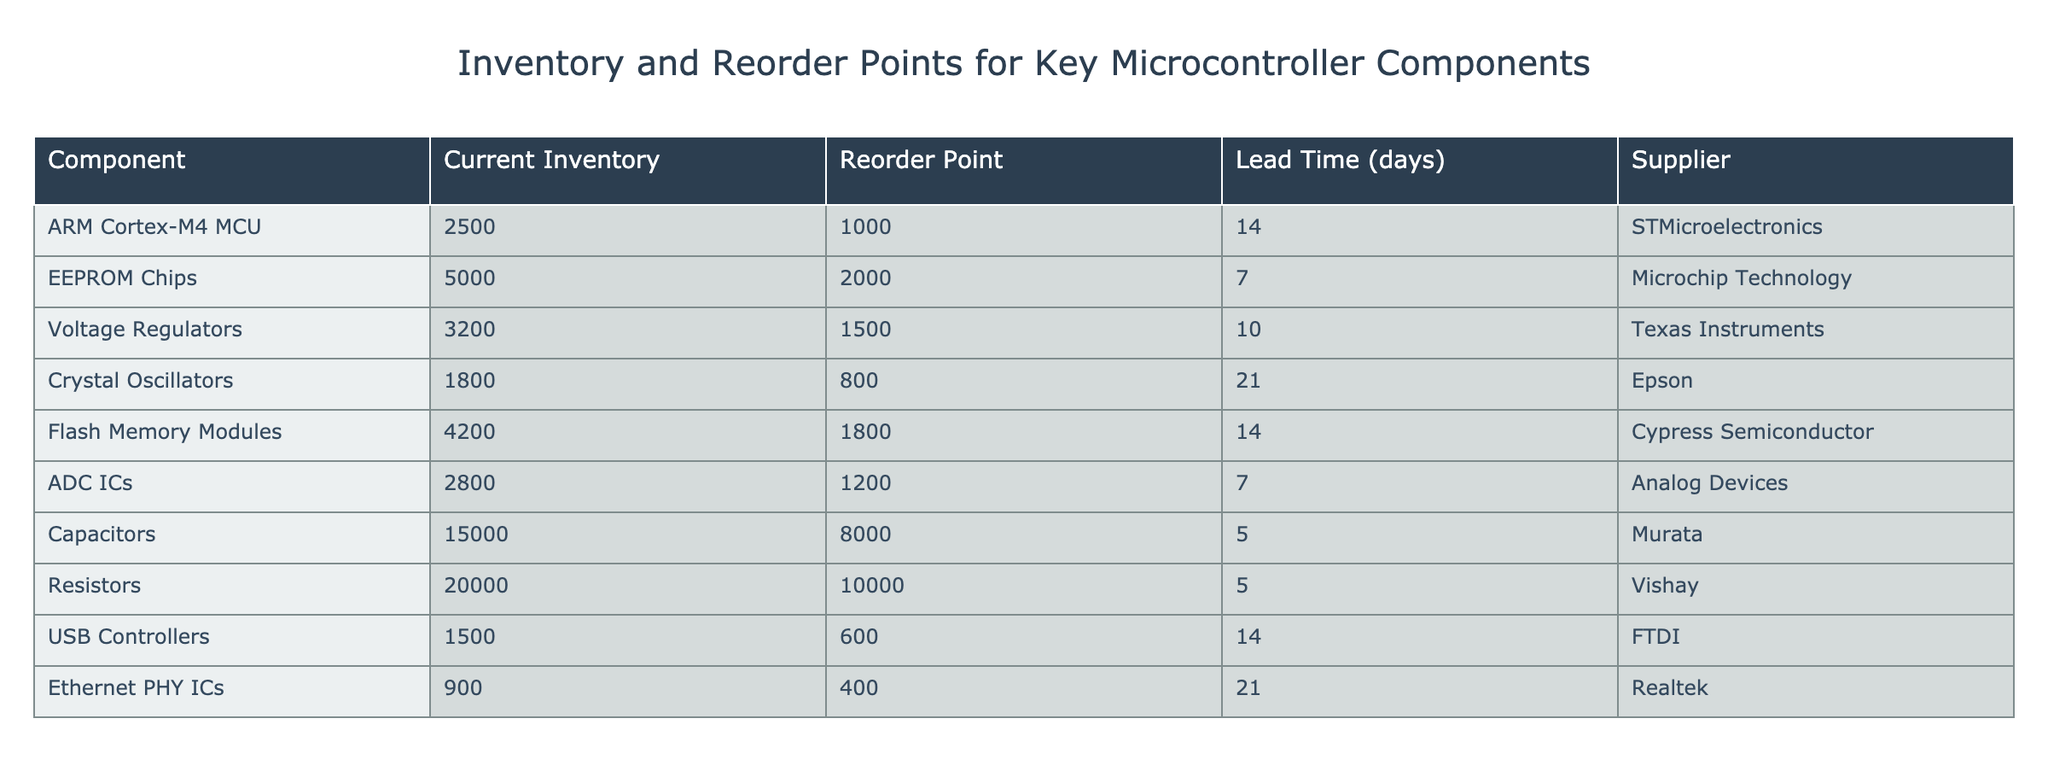What is the current inventory level of the ARM Cortex-M4 MCU? The table indicates that the current inventory level of the ARM Cortex-M4 MCU is listed directly under the "Current Inventory" column. The value shown is 2500.
Answer: 2500 How many days of lead time do Voltage Regulators have? The lead time for Voltage Regulators is specified in the "Lead Time (days)" column. The table shows that the lead time for Voltage Regulators is 10 days.
Answer: 10 What is the difference in current inventory between EEPROM Chips and Flash Memory Modules? To find the difference, first, identify the current inventory for both components. EEPROM Chips have an inventory of 5000, while Flash Memory Modules have 4200. The difference is calculated as 5000 - 4200 = 800.
Answer: 800 Is the reorder point for Crystal Oscillators greater than the reorder point for USB Controllers? By comparing the reorder points in the corresponding columns, Crystal Oscillators have a reorder point of 800 and USB Controllers have 600. Since 800 is greater than 600, the answer is yes.
Answer: Yes What is the average current inventory for all components listed in the table? To calculate the average inventory, first sum the current inventory levels for all components: 2500 + 5000 + 3200 + 1800 + 4200 + 2800 + 15000 + 20000 + 1500 + 900 = 62800. Then, divide by the number of components (10): 62800 / 10 = 6280.
Answer: 6280 Which component has the highest reorder point? The reorder points for all components can be compared. The highest reorder point in the table is for Resistors, which is set at 10000.
Answer: 10000 What is the total current inventory of capacitors and resistors combined? Find the current inventory of capacitors, which is 15000, and for resistors, which is 20000. Add those two values together: 15000 + 20000 = 35000.
Answer: 35000 How many components have a lead time longer than 20 days? Review the "Lead Time (days)" column for each component. Only the Crystal Oscillators (21 days) and Ethernet PHY ICs (21 days) have a lead time longer than 20 days. Thus, there are 2 components that meet this criterion.
Answer: 2 